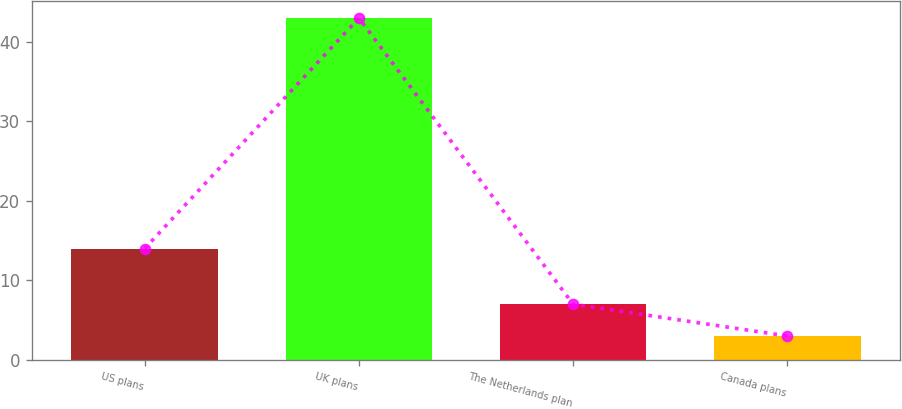<chart> <loc_0><loc_0><loc_500><loc_500><bar_chart><fcel>US plans<fcel>UK plans<fcel>The Netherlands plan<fcel>Canada plans<nl><fcel>14<fcel>43<fcel>7<fcel>3<nl></chart> 